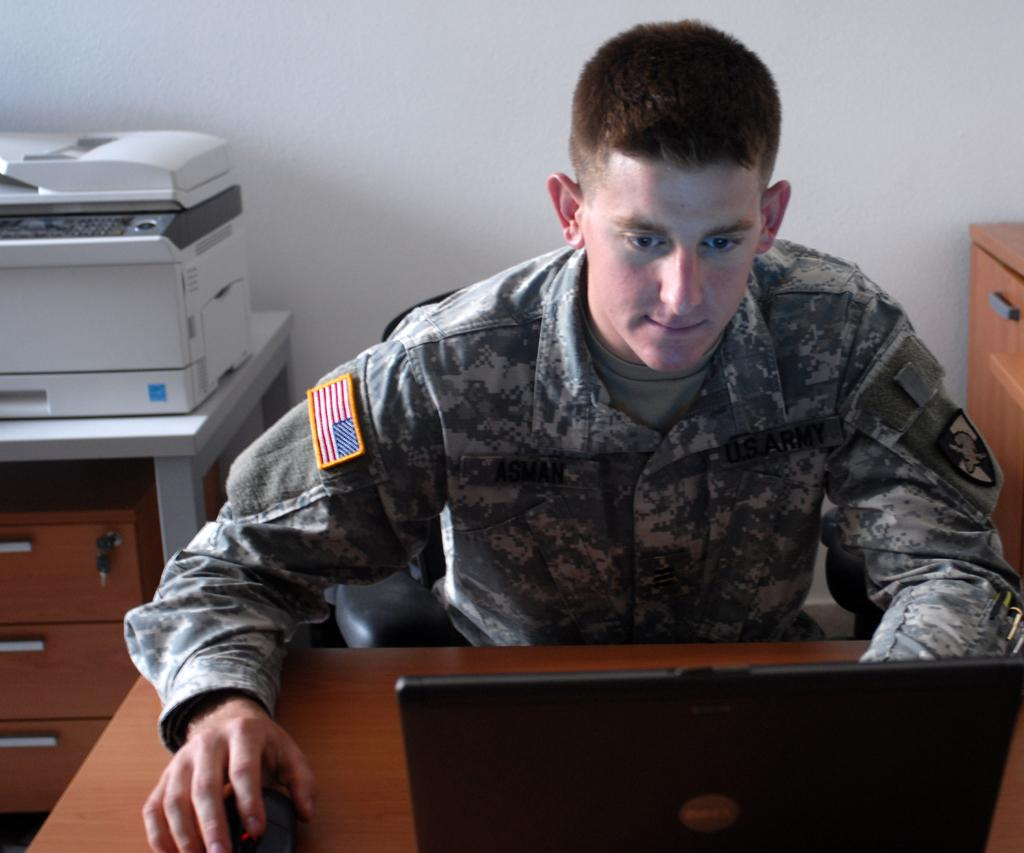What is the person in the image doing? The person is operating a laptop. What type of clothing is the person wearing? The person is wearing a military dress. What other office equipment can be seen in the image? There is a printer in the background of the image. What is visible in the background of the image? There is a wall in the background of the image. What type of glove is the person wearing while cooking in the image? There is no glove or cooking activity present in the image. How does the person reduce friction while operating the laptop in the image? The person is not shown reducing friction while operating the laptop in the image. 